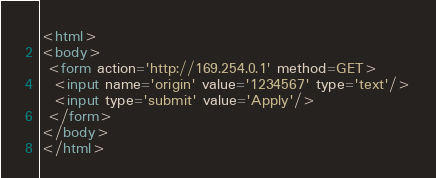Convert code to text. <code><loc_0><loc_0><loc_500><loc_500><_HTML_><html>
<body>
 <form action='http://169.254.0.1' method=GET>
  <input name='origin' value='1234567' type='text'/>
  <input type='submit' value='Apply'/>
 </form>
</body>
</html>
</code> 